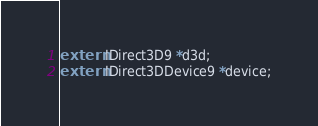Convert code to text. <code><loc_0><loc_0><loc_500><loc_500><_C_>extern IDirect3D9 *d3d;
extern IDirect3DDevice9 *device;
</code> 